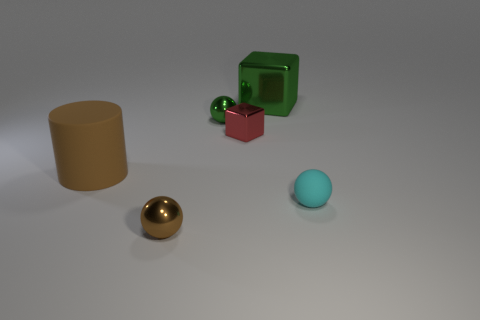How many cylinders are either large rubber things or tiny rubber objects?
Make the answer very short. 1. Are there any other metallic things that have the same shape as the small cyan object?
Offer a very short reply. Yes. What is the shape of the brown matte object?
Your response must be concise. Cylinder. What number of things are either tiny matte things or large cyan matte cylinders?
Offer a terse response. 1. Does the rubber object that is to the right of the brown cylinder have the same size as the metal object that is in front of the tiny red thing?
Offer a very short reply. Yes. How many other objects are the same material as the small red cube?
Provide a short and direct response. 3. Are there more brown matte objects that are left of the tiny rubber object than red metal objects that are to the left of the cylinder?
Provide a succinct answer. Yes. What is the material of the red thing that is behind the brown metallic object?
Offer a very short reply. Metal. Is the shape of the large green thing the same as the tiny red metallic object?
Provide a short and direct response. Yes. Are there any other things of the same color as the small rubber ball?
Your response must be concise. No. 